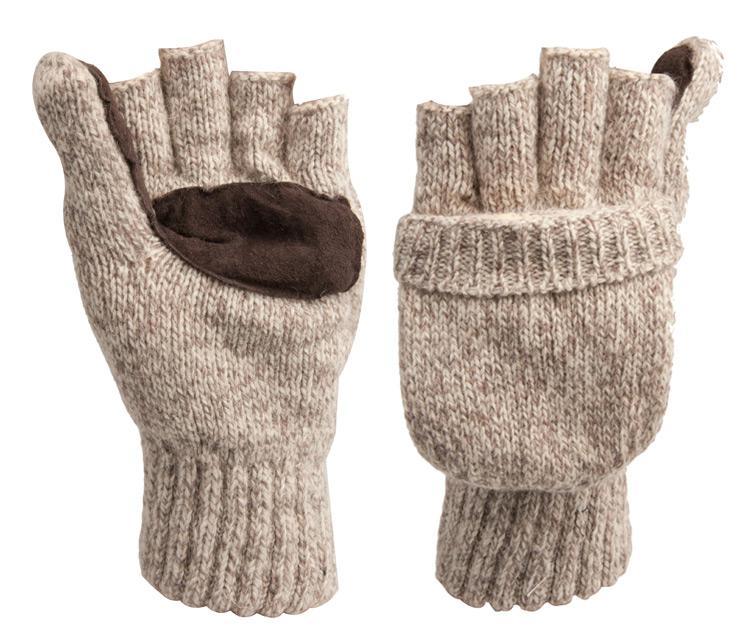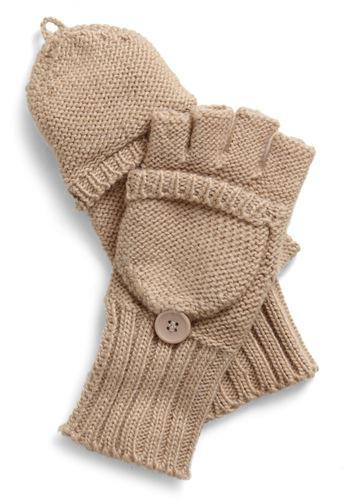The first image is the image on the left, the second image is the image on the right. For the images shown, is this caption "A closed round mitten is faced palms down with the thumb part on the left side." true? Answer yes or no. No. The first image is the image on the left, the second image is the image on the right. Analyze the images presented: Is the assertion "One pair of mittens is solid camel colored, and the other is heather colored with a dark brown patch." valid? Answer yes or no. Yes. 